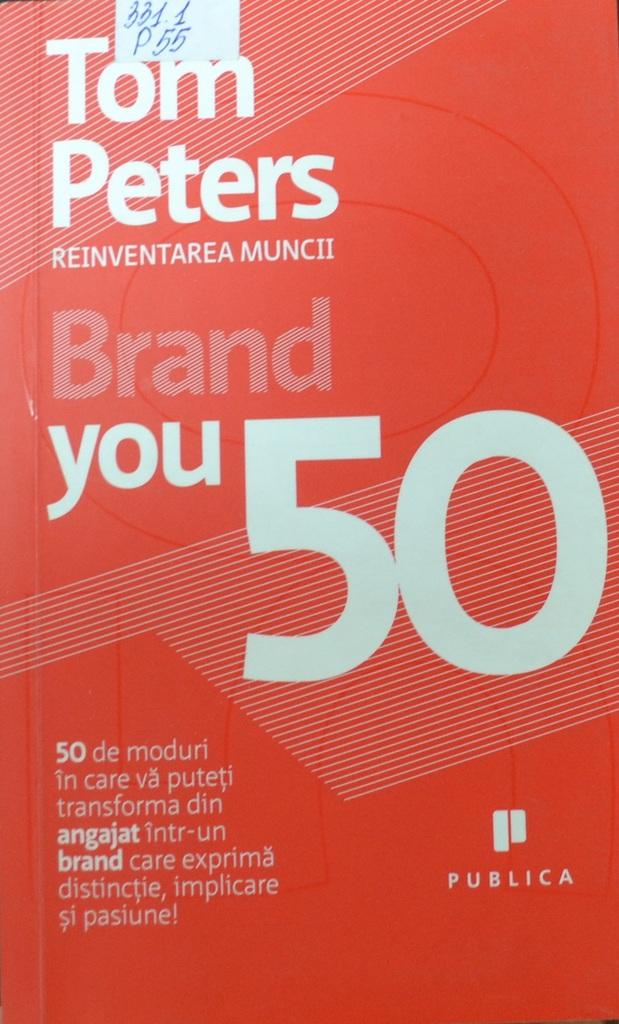Provide a one-sentence caption for the provided image. A red covered book titled Brand Your 50. 